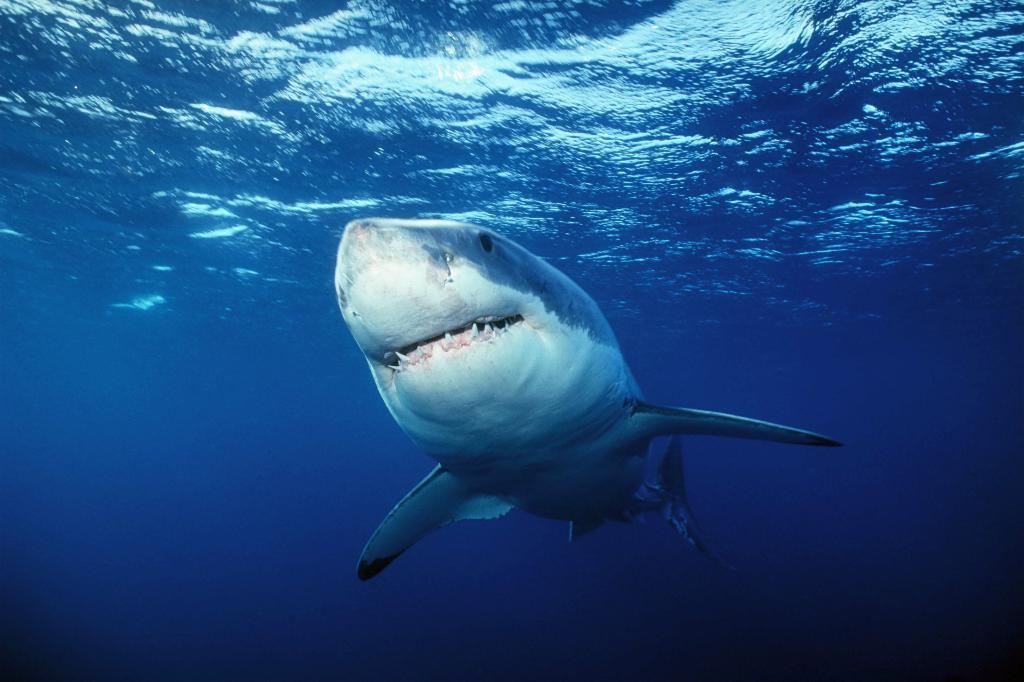What type of animal can be seen in the image? There is an aquatic animal in the image. Where is the aquatic animal located? The aquatic animal is in the water. What type of table is visible in the image? There is no table present in the image; it features an aquatic animal in the water. How does the aquatic animal cough in the image? Aquatic animals do not have the ability to cough, as they are not mammals and do not have lungs. 